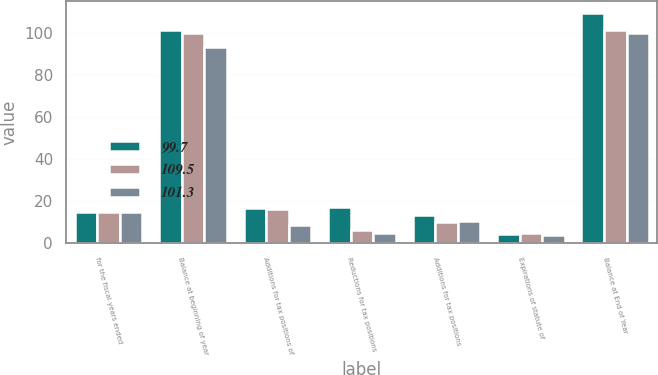Convert chart. <chart><loc_0><loc_0><loc_500><loc_500><stacked_bar_chart><ecel><fcel>for the fiscal years ended<fcel>Balance at beginning of year<fcel>Additions for tax positions of<fcel>Reductions for tax positions<fcel>Additions for tax positions<fcel>Expirations of statute of<fcel>Balance at End of Year<nl><fcel>99.7<fcel>14.9<fcel>101.3<fcel>16.5<fcel>17.1<fcel>13.4<fcel>4.6<fcel>109.5<nl><fcel>109.5<fcel>14.9<fcel>99.7<fcel>16.4<fcel>6.3<fcel>10<fcel>4.8<fcel>101.3<nl><fcel>101.3<fcel>14.9<fcel>93.3<fcel>8.8<fcel>5.1<fcel>10.8<fcel>3.9<fcel>99.7<nl></chart> 